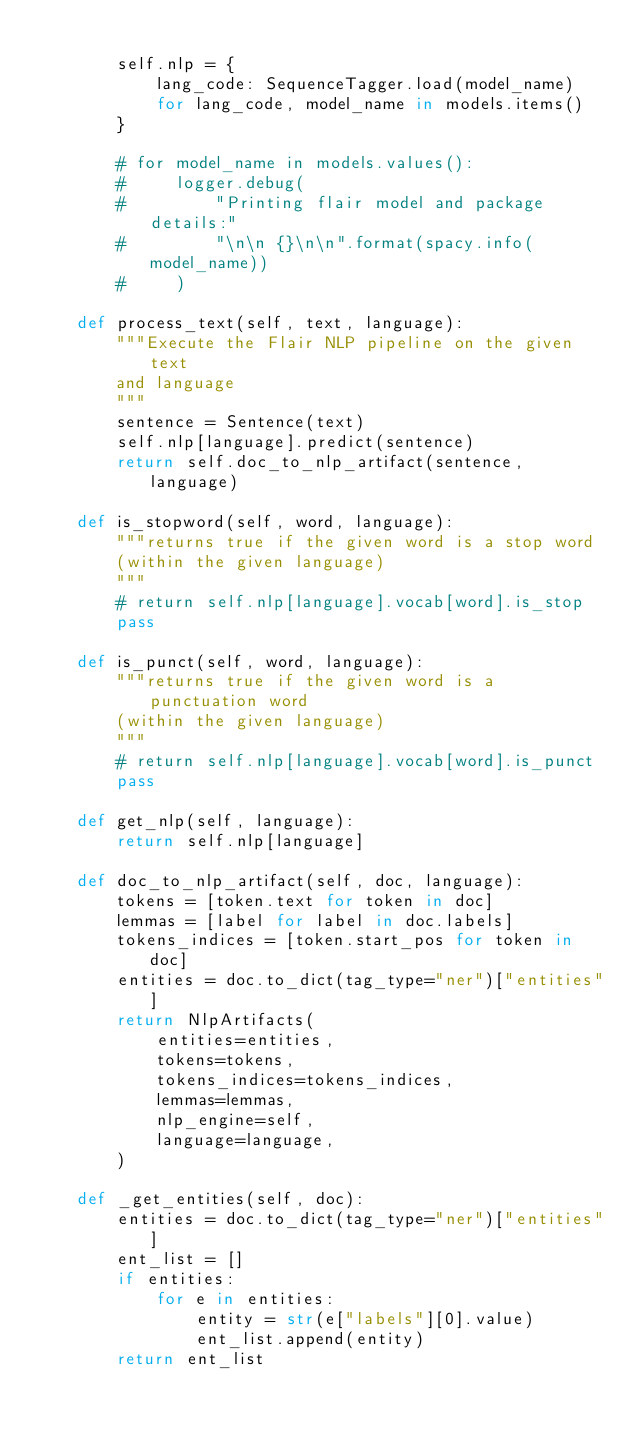Convert code to text. <code><loc_0><loc_0><loc_500><loc_500><_Python_>
        self.nlp = {
            lang_code: SequenceTagger.load(model_name)
            for lang_code, model_name in models.items()
        }

        # for model_name in models.values():
        #     logger.debug(
        #         "Printing flair model and package details:"
        #         "\n\n {}\n\n".format(spacy.info(model_name))
        #     )

    def process_text(self, text, language):
        """Execute the Flair NLP pipeline on the given text
        and language
        """
        sentence = Sentence(text)
        self.nlp[language].predict(sentence)
        return self.doc_to_nlp_artifact(sentence, language)

    def is_stopword(self, word, language):
        """returns true if the given word is a stop word
        (within the given language)
        """
        # return self.nlp[language].vocab[word].is_stop
        pass

    def is_punct(self, word, language):
        """returns true if the given word is a punctuation word
        (within the given language)
        """
        # return self.nlp[language].vocab[word].is_punct
        pass

    def get_nlp(self, language):
        return self.nlp[language]

    def doc_to_nlp_artifact(self, doc, language):
        tokens = [token.text for token in doc]
        lemmas = [label for label in doc.labels]
        tokens_indices = [token.start_pos for token in doc]
        entities = doc.to_dict(tag_type="ner")["entities"]
        return NlpArtifacts(
            entities=entities,
            tokens=tokens,
            tokens_indices=tokens_indices,
            lemmas=lemmas,
            nlp_engine=self,
            language=language,
        )

    def _get_entities(self, doc):
        entities = doc.to_dict(tag_type="ner")["entities"]
        ent_list = []
        if entities:
            for e in entities:
                entity = str(e["labels"][0].value)
                ent_list.append(entity)
        return ent_list</code> 